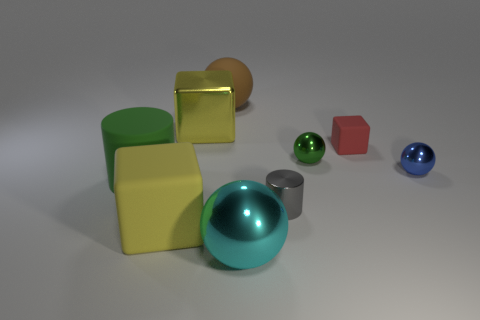Subtract all tiny green metallic balls. How many balls are left? 3 Subtract all cyan spheres. How many spheres are left? 3 Subtract all purple balls. Subtract all brown cylinders. How many balls are left? 4 Subtract all cylinders. How many objects are left? 7 Add 8 purple metal cylinders. How many purple metal cylinders exist? 8 Subtract 1 cyan spheres. How many objects are left? 8 Subtract all tiny yellow things. Subtract all tiny cubes. How many objects are left? 8 Add 3 big brown rubber spheres. How many big brown rubber spheres are left? 4 